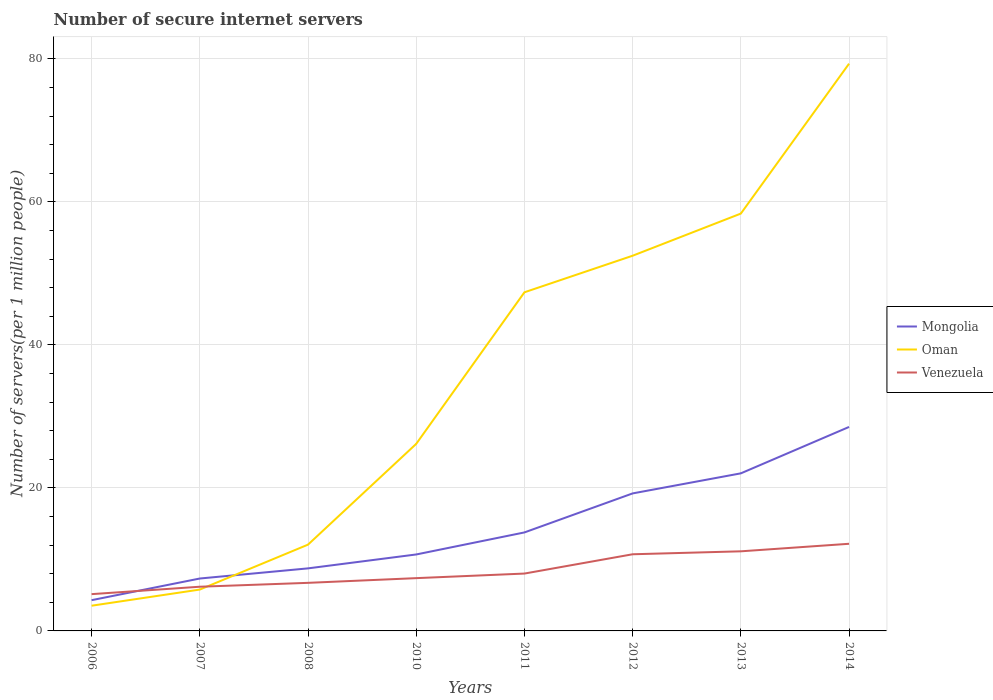Across all years, what is the maximum number of secure internet servers in Mongolia?
Provide a succinct answer. 4.3. In which year was the number of secure internet servers in Mongolia maximum?
Provide a succinct answer. 2006. What is the total number of secure internet servers in Mongolia in the graph?
Keep it short and to the point. -3.03. What is the difference between the highest and the second highest number of secure internet servers in Mongolia?
Your answer should be compact. 24.22. How many lines are there?
Make the answer very short. 3. How many years are there in the graph?
Keep it short and to the point. 8. Does the graph contain grids?
Ensure brevity in your answer.  Yes. Where does the legend appear in the graph?
Ensure brevity in your answer.  Center right. How many legend labels are there?
Provide a short and direct response. 3. How are the legend labels stacked?
Offer a terse response. Vertical. What is the title of the graph?
Your response must be concise. Number of secure internet servers. Does "Macao" appear as one of the legend labels in the graph?
Ensure brevity in your answer.  No. What is the label or title of the X-axis?
Your response must be concise. Years. What is the label or title of the Y-axis?
Ensure brevity in your answer.  Number of servers(per 1 million people). What is the Number of servers(per 1 million people) of Mongolia in 2006?
Provide a succinct answer. 4.3. What is the Number of servers(per 1 million people) of Oman in 2006?
Keep it short and to the point. 3.52. What is the Number of servers(per 1 million people) in Venezuela in 2006?
Keep it short and to the point. 5.14. What is the Number of servers(per 1 million people) in Mongolia in 2007?
Your response must be concise. 7.33. What is the Number of servers(per 1 million people) of Oman in 2007?
Offer a very short reply. 5.78. What is the Number of servers(per 1 million people) in Venezuela in 2007?
Your response must be concise. 6.18. What is the Number of servers(per 1 million people) in Mongolia in 2008?
Ensure brevity in your answer.  8.75. What is the Number of servers(per 1 million people) in Oman in 2008?
Offer a terse response. 12.07. What is the Number of servers(per 1 million people) in Venezuela in 2008?
Provide a short and direct response. 6.72. What is the Number of servers(per 1 million people) in Mongolia in 2010?
Provide a succinct answer. 10.69. What is the Number of servers(per 1 million people) of Oman in 2010?
Your answer should be very brief. 26.16. What is the Number of servers(per 1 million people) of Venezuela in 2010?
Make the answer very short. 7.38. What is the Number of servers(per 1 million people) of Mongolia in 2011?
Offer a very short reply. 13.77. What is the Number of servers(per 1 million people) in Oman in 2011?
Your answer should be very brief. 47.35. What is the Number of servers(per 1 million people) in Venezuela in 2011?
Offer a very short reply. 8.02. What is the Number of servers(per 1 million people) in Mongolia in 2012?
Your answer should be very brief. 19.23. What is the Number of servers(per 1 million people) in Oman in 2012?
Your answer should be very brief. 52.47. What is the Number of servers(per 1 million people) of Venezuela in 2012?
Give a very brief answer. 10.72. What is the Number of servers(per 1 million people) in Mongolia in 2013?
Offer a very short reply. 22.03. What is the Number of servers(per 1 million people) of Oman in 2013?
Your answer should be very brief. 58.36. What is the Number of servers(per 1 million people) of Venezuela in 2013?
Give a very brief answer. 11.13. What is the Number of servers(per 1 million people) in Mongolia in 2014?
Provide a short and direct response. 28.52. What is the Number of servers(per 1 million people) in Oman in 2014?
Provide a succinct answer. 79.32. What is the Number of servers(per 1 million people) of Venezuela in 2014?
Give a very brief answer. 12.18. Across all years, what is the maximum Number of servers(per 1 million people) in Mongolia?
Your response must be concise. 28.52. Across all years, what is the maximum Number of servers(per 1 million people) in Oman?
Your answer should be compact. 79.32. Across all years, what is the maximum Number of servers(per 1 million people) of Venezuela?
Keep it short and to the point. 12.18. Across all years, what is the minimum Number of servers(per 1 million people) of Mongolia?
Keep it short and to the point. 4.3. Across all years, what is the minimum Number of servers(per 1 million people) in Oman?
Your response must be concise. 3.52. Across all years, what is the minimum Number of servers(per 1 million people) of Venezuela?
Your answer should be compact. 5.14. What is the total Number of servers(per 1 million people) of Mongolia in the graph?
Your answer should be compact. 114.62. What is the total Number of servers(per 1 million people) of Oman in the graph?
Your answer should be compact. 285.02. What is the total Number of servers(per 1 million people) in Venezuela in the graph?
Give a very brief answer. 67.48. What is the difference between the Number of servers(per 1 million people) in Mongolia in 2006 and that in 2007?
Your answer should be compact. -3.03. What is the difference between the Number of servers(per 1 million people) in Oman in 2006 and that in 2007?
Your answer should be very brief. -2.26. What is the difference between the Number of servers(per 1 million people) in Venezuela in 2006 and that in 2007?
Keep it short and to the point. -1.04. What is the difference between the Number of servers(per 1 million people) of Mongolia in 2006 and that in 2008?
Make the answer very short. -4.45. What is the difference between the Number of servers(per 1 million people) in Oman in 2006 and that in 2008?
Offer a very short reply. -8.54. What is the difference between the Number of servers(per 1 million people) of Venezuela in 2006 and that in 2008?
Keep it short and to the point. -1.58. What is the difference between the Number of servers(per 1 million people) of Mongolia in 2006 and that in 2010?
Your answer should be very brief. -6.39. What is the difference between the Number of servers(per 1 million people) in Oman in 2006 and that in 2010?
Your response must be concise. -22.63. What is the difference between the Number of servers(per 1 million people) in Venezuela in 2006 and that in 2010?
Your answer should be very brief. -2.24. What is the difference between the Number of servers(per 1 million people) in Mongolia in 2006 and that in 2011?
Offer a very short reply. -9.47. What is the difference between the Number of servers(per 1 million people) in Oman in 2006 and that in 2011?
Keep it short and to the point. -43.83. What is the difference between the Number of servers(per 1 million people) of Venezuela in 2006 and that in 2011?
Offer a very short reply. -2.88. What is the difference between the Number of servers(per 1 million people) in Mongolia in 2006 and that in 2012?
Your answer should be very brief. -14.93. What is the difference between the Number of servers(per 1 million people) of Oman in 2006 and that in 2012?
Provide a succinct answer. -48.94. What is the difference between the Number of servers(per 1 million people) in Venezuela in 2006 and that in 2012?
Offer a very short reply. -5.58. What is the difference between the Number of servers(per 1 million people) in Mongolia in 2006 and that in 2013?
Keep it short and to the point. -17.73. What is the difference between the Number of servers(per 1 million people) in Oman in 2006 and that in 2013?
Your answer should be very brief. -54.83. What is the difference between the Number of servers(per 1 million people) in Venezuela in 2006 and that in 2013?
Offer a terse response. -5.99. What is the difference between the Number of servers(per 1 million people) of Mongolia in 2006 and that in 2014?
Offer a very short reply. -24.22. What is the difference between the Number of servers(per 1 million people) in Oman in 2006 and that in 2014?
Your response must be concise. -75.79. What is the difference between the Number of servers(per 1 million people) in Venezuela in 2006 and that in 2014?
Offer a terse response. -7.04. What is the difference between the Number of servers(per 1 million people) in Mongolia in 2007 and that in 2008?
Provide a short and direct response. -1.42. What is the difference between the Number of servers(per 1 million people) of Oman in 2007 and that in 2008?
Give a very brief answer. -6.28. What is the difference between the Number of servers(per 1 million people) in Venezuela in 2007 and that in 2008?
Provide a succinct answer. -0.54. What is the difference between the Number of servers(per 1 million people) in Mongolia in 2007 and that in 2010?
Make the answer very short. -3.36. What is the difference between the Number of servers(per 1 million people) in Oman in 2007 and that in 2010?
Make the answer very short. -20.37. What is the difference between the Number of servers(per 1 million people) in Venezuela in 2007 and that in 2010?
Your answer should be compact. -1.2. What is the difference between the Number of servers(per 1 million people) of Mongolia in 2007 and that in 2011?
Give a very brief answer. -6.44. What is the difference between the Number of servers(per 1 million people) of Oman in 2007 and that in 2011?
Give a very brief answer. -41.57. What is the difference between the Number of servers(per 1 million people) in Venezuela in 2007 and that in 2011?
Give a very brief answer. -1.84. What is the difference between the Number of servers(per 1 million people) of Mongolia in 2007 and that in 2012?
Offer a very short reply. -11.9. What is the difference between the Number of servers(per 1 million people) in Oman in 2007 and that in 2012?
Your answer should be very brief. -46.68. What is the difference between the Number of servers(per 1 million people) in Venezuela in 2007 and that in 2012?
Make the answer very short. -4.54. What is the difference between the Number of servers(per 1 million people) in Mongolia in 2007 and that in 2013?
Offer a very short reply. -14.71. What is the difference between the Number of servers(per 1 million people) of Oman in 2007 and that in 2013?
Keep it short and to the point. -52.58. What is the difference between the Number of servers(per 1 million people) in Venezuela in 2007 and that in 2013?
Give a very brief answer. -4.95. What is the difference between the Number of servers(per 1 million people) of Mongolia in 2007 and that in 2014?
Give a very brief answer. -21.2. What is the difference between the Number of servers(per 1 million people) of Oman in 2007 and that in 2014?
Offer a very short reply. -73.54. What is the difference between the Number of servers(per 1 million people) of Venezuela in 2007 and that in 2014?
Offer a terse response. -6. What is the difference between the Number of servers(per 1 million people) of Mongolia in 2008 and that in 2010?
Your answer should be very brief. -1.94. What is the difference between the Number of servers(per 1 million people) in Oman in 2008 and that in 2010?
Ensure brevity in your answer.  -14.09. What is the difference between the Number of servers(per 1 million people) in Venezuela in 2008 and that in 2010?
Provide a succinct answer. -0.66. What is the difference between the Number of servers(per 1 million people) in Mongolia in 2008 and that in 2011?
Your answer should be very brief. -5.03. What is the difference between the Number of servers(per 1 million people) in Oman in 2008 and that in 2011?
Give a very brief answer. -35.29. What is the difference between the Number of servers(per 1 million people) of Venezuela in 2008 and that in 2011?
Keep it short and to the point. -1.3. What is the difference between the Number of servers(per 1 million people) in Mongolia in 2008 and that in 2012?
Your answer should be compact. -10.48. What is the difference between the Number of servers(per 1 million people) of Oman in 2008 and that in 2012?
Provide a short and direct response. -40.4. What is the difference between the Number of servers(per 1 million people) in Venezuela in 2008 and that in 2012?
Provide a short and direct response. -4. What is the difference between the Number of servers(per 1 million people) in Mongolia in 2008 and that in 2013?
Your response must be concise. -13.29. What is the difference between the Number of servers(per 1 million people) in Oman in 2008 and that in 2013?
Keep it short and to the point. -46.29. What is the difference between the Number of servers(per 1 million people) in Venezuela in 2008 and that in 2013?
Your answer should be very brief. -4.41. What is the difference between the Number of servers(per 1 million people) of Mongolia in 2008 and that in 2014?
Your response must be concise. -19.78. What is the difference between the Number of servers(per 1 million people) of Oman in 2008 and that in 2014?
Provide a short and direct response. -67.25. What is the difference between the Number of servers(per 1 million people) of Venezuela in 2008 and that in 2014?
Ensure brevity in your answer.  -5.46. What is the difference between the Number of servers(per 1 million people) of Mongolia in 2010 and that in 2011?
Ensure brevity in your answer.  -3.08. What is the difference between the Number of servers(per 1 million people) in Oman in 2010 and that in 2011?
Offer a very short reply. -21.19. What is the difference between the Number of servers(per 1 million people) in Venezuela in 2010 and that in 2011?
Give a very brief answer. -0.64. What is the difference between the Number of servers(per 1 million people) of Mongolia in 2010 and that in 2012?
Keep it short and to the point. -8.54. What is the difference between the Number of servers(per 1 million people) in Oman in 2010 and that in 2012?
Your answer should be very brief. -26.31. What is the difference between the Number of servers(per 1 million people) in Venezuela in 2010 and that in 2012?
Offer a very short reply. -3.34. What is the difference between the Number of servers(per 1 million people) in Mongolia in 2010 and that in 2013?
Provide a succinct answer. -11.34. What is the difference between the Number of servers(per 1 million people) of Oman in 2010 and that in 2013?
Provide a succinct answer. -32.2. What is the difference between the Number of servers(per 1 million people) of Venezuela in 2010 and that in 2013?
Ensure brevity in your answer.  -3.75. What is the difference between the Number of servers(per 1 million people) in Mongolia in 2010 and that in 2014?
Ensure brevity in your answer.  -17.83. What is the difference between the Number of servers(per 1 million people) of Oman in 2010 and that in 2014?
Offer a terse response. -53.16. What is the difference between the Number of servers(per 1 million people) of Venezuela in 2010 and that in 2014?
Your response must be concise. -4.8. What is the difference between the Number of servers(per 1 million people) in Mongolia in 2011 and that in 2012?
Provide a short and direct response. -5.46. What is the difference between the Number of servers(per 1 million people) in Oman in 2011 and that in 2012?
Make the answer very short. -5.11. What is the difference between the Number of servers(per 1 million people) of Venezuela in 2011 and that in 2012?
Offer a very short reply. -2.7. What is the difference between the Number of servers(per 1 million people) in Mongolia in 2011 and that in 2013?
Provide a short and direct response. -8.26. What is the difference between the Number of servers(per 1 million people) of Oman in 2011 and that in 2013?
Keep it short and to the point. -11.01. What is the difference between the Number of servers(per 1 million people) of Venezuela in 2011 and that in 2013?
Keep it short and to the point. -3.11. What is the difference between the Number of servers(per 1 million people) of Mongolia in 2011 and that in 2014?
Provide a short and direct response. -14.75. What is the difference between the Number of servers(per 1 million people) in Oman in 2011 and that in 2014?
Provide a succinct answer. -31.97. What is the difference between the Number of servers(per 1 million people) in Venezuela in 2011 and that in 2014?
Give a very brief answer. -4.17. What is the difference between the Number of servers(per 1 million people) in Mongolia in 2012 and that in 2013?
Keep it short and to the point. -2.81. What is the difference between the Number of servers(per 1 million people) of Oman in 2012 and that in 2013?
Ensure brevity in your answer.  -5.89. What is the difference between the Number of servers(per 1 million people) of Venezuela in 2012 and that in 2013?
Make the answer very short. -0.41. What is the difference between the Number of servers(per 1 million people) of Mongolia in 2012 and that in 2014?
Ensure brevity in your answer.  -9.3. What is the difference between the Number of servers(per 1 million people) of Oman in 2012 and that in 2014?
Offer a terse response. -26.85. What is the difference between the Number of servers(per 1 million people) of Venezuela in 2012 and that in 2014?
Provide a short and direct response. -1.47. What is the difference between the Number of servers(per 1 million people) in Mongolia in 2013 and that in 2014?
Make the answer very short. -6.49. What is the difference between the Number of servers(per 1 million people) of Oman in 2013 and that in 2014?
Keep it short and to the point. -20.96. What is the difference between the Number of servers(per 1 million people) of Venezuela in 2013 and that in 2014?
Offer a very short reply. -1.05. What is the difference between the Number of servers(per 1 million people) in Mongolia in 2006 and the Number of servers(per 1 million people) in Oman in 2007?
Offer a very short reply. -1.48. What is the difference between the Number of servers(per 1 million people) in Mongolia in 2006 and the Number of servers(per 1 million people) in Venezuela in 2007?
Your response must be concise. -1.88. What is the difference between the Number of servers(per 1 million people) in Oman in 2006 and the Number of servers(per 1 million people) in Venezuela in 2007?
Keep it short and to the point. -2.66. What is the difference between the Number of servers(per 1 million people) of Mongolia in 2006 and the Number of servers(per 1 million people) of Oman in 2008?
Provide a short and direct response. -7.77. What is the difference between the Number of servers(per 1 million people) of Mongolia in 2006 and the Number of servers(per 1 million people) of Venezuela in 2008?
Your answer should be compact. -2.42. What is the difference between the Number of servers(per 1 million people) of Oman in 2006 and the Number of servers(per 1 million people) of Venezuela in 2008?
Make the answer very short. -3.2. What is the difference between the Number of servers(per 1 million people) of Mongolia in 2006 and the Number of servers(per 1 million people) of Oman in 2010?
Offer a very short reply. -21.86. What is the difference between the Number of servers(per 1 million people) in Mongolia in 2006 and the Number of servers(per 1 million people) in Venezuela in 2010?
Your answer should be very brief. -3.08. What is the difference between the Number of servers(per 1 million people) in Oman in 2006 and the Number of servers(per 1 million people) in Venezuela in 2010?
Provide a short and direct response. -3.86. What is the difference between the Number of servers(per 1 million people) of Mongolia in 2006 and the Number of servers(per 1 million people) of Oman in 2011?
Offer a very short reply. -43.05. What is the difference between the Number of servers(per 1 million people) of Mongolia in 2006 and the Number of servers(per 1 million people) of Venezuela in 2011?
Keep it short and to the point. -3.72. What is the difference between the Number of servers(per 1 million people) of Oman in 2006 and the Number of servers(per 1 million people) of Venezuela in 2011?
Provide a succinct answer. -4.49. What is the difference between the Number of servers(per 1 million people) of Mongolia in 2006 and the Number of servers(per 1 million people) of Oman in 2012?
Offer a terse response. -48.17. What is the difference between the Number of servers(per 1 million people) of Mongolia in 2006 and the Number of servers(per 1 million people) of Venezuela in 2012?
Give a very brief answer. -6.42. What is the difference between the Number of servers(per 1 million people) in Oman in 2006 and the Number of servers(per 1 million people) in Venezuela in 2012?
Give a very brief answer. -7.19. What is the difference between the Number of servers(per 1 million people) in Mongolia in 2006 and the Number of servers(per 1 million people) in Oman in 2013?
Give a very brief answer. -54.06. What is the difference between the Number of servers(per 1 million people) in Mongolia in 2006 and the Number of servers(per 1 million people) in Venezuela in 2013?
Keep it short and to the point. -6.83. What is the difference between the Number of servers(per 1 million people) in Oman in 2006 and the Number of servers(per 1 million people) in Venezuela in 2013?
Give a very brief answer. -7.61. What is the difference between the Number of servers(per 1 million people) in Mongolia in 2006 and the Number of servers(per 1 million people) in Oman in 2014?
Offer a terse response. -75.02. What is the difference between the Number of servers(per 1 million people) in Mongolia in 2006 and the Number of servers(per 1 million people) in Venezuela in 2014?
Your answer should be very brief. -7.89. What is the difference between the Number of servers(per 1 million people) of Oman in 2006 and the Number of servers(per 1 million people) of Venezuela in 2014?
Make the answer very short. -8.66. What is the difference between the Number of servers(per 1 million people) of Mongolia in 2007 and the Number of servers(per 1 million people) of Oman in 2008?
Give a very brief answer. -4.74. What is the difference between the Number of servers(per 1 million people) in Mongolia in 2007 and the Number of servers(per 1 million people) in Venezuela in 2008?
Your response must be concise. 0.61. What is the difference between the Number of servers(per 1 million people) of Oman in 2007 and the Number of servers(per 1 million people) of Venezuela in 2008?
Ensure brevity in your answer.  -0.94. What is the difference between the Number of servers(per 1 million people) of Mongolia in 2007 and the Number of servers(per 1 million people) of Oman in 2010?
Give a very brief answer. -18.83. What is the difference between the Number of servers(per 1 million people) in Mongolia in 2007 and the Number of servers(per 1 million people) in Venezuela in 2010?
Your response must be concise. -0.05. What is the difference between the Number of servers(per 1 million people) in Oman in 2007 and the Number of servers(per 1 million people) in Venezuela in 2010?
Offer a terse response. -1.6. What is the difference between the Number of servers(per 1 million people) in Mongolia in 2007 and the Number of servers(per 1 million people) in Oman in 2011?
Provide a succinct answer. -40.02. What is the difference between the Number of servers(per 1 million people) in Mongolia in 2007 and the Number of servers(per 1 million people) in Venezuela in 2011?
Your answer should be compact. -0.69. What is the difference between the Number of servers(per 1 million people) of Oman in 2007 and the Number of servers(per 1 million people) of Venezuela in 2011?
Your answer should be compact. -2.24. What is the difference between the Number of servers(per 1 million people) of Mongolia in 2007 and the Number of servers(per 1 million people) of Oman in 2012?
Provide a short and direct response. -45.14. What is the difference between the Number of servers(per 1 million people) in Mongolia in 2007 and the Number of servers(per 1 million people) in Venezuela in 2012?
Your response must be concise. -3.39. What is the difference between the Number of servers(per 1 million people) in Oman in 2007 and the Number of servers(per 1 million people) in Venezuela in 2012?
Provide a succinct answer. -4.94. What is the difference between the Number of servers(per 1 million people) in Mongolia in 2007 and the Number of servers(per 1 million people) in Oman in 2013?
Your response must be concise. -51.03. What is the difference between the Number of servers(per 1 million people) in Mongolia in 2007 and the Number of servers(per 1 million people) in Venezuela in 2013?
Your response must be concise. -3.8. What is the difference between the Number of servers(per 1 million people) in Oman in 2007 and the Number of servers(per 1 million people) in Venezuela in 2013?
Keep it short and to the point. -5.35. What is the difference between the Number of servers(per 1 million people) of Mongolia in 2007 and the Number of servers(per 1 million people) of Oman in 2014?
Your answer should be very brief. -71.99. What is the difference between the Number of servers(per 1 million people) of Mongolia in 2007 and the Number of servers(per 1 million people) of Venezuela in 2014?
Make the answer very short. -4.86. What is the difference between the Number of servers(per 1 million people) of Oman in 2007 and the Number of servers(per 1 million people) of Venezuela in 2014?
Your answer should be compact. -6.4. What is the difference between the Number of servers(per 1 million people) in Mongolia in 2008 and the Number of servers(per 1 million people) in Oman in 2010?
Your answer should be very brief. -17.41. What is the difference between the Number of servers(per 1 million people) in Mongolia in 2008 and the Number of servers(per 1 million people) in Venezuela in 2010?
Provide a short and direct response. 1.37. What is the difference between the Number of servers(per 1 million people) in Oman in 2008 and the Number of servers(per 1 million people) in Venezuela in 2010?
Offer a terse response. 4.68. What is the difference between the Number of servers(per 1 million people) in Mongolia in 2008 and the Number of servers(per 1 million people) in Oman in 2011?
Make the answer very short. -38.61. What is the difference between the Number of servers(per 1 million people) in Mongolia in 2008 and the Number of servers(per 1 million people) in Venezuela in 2011?
Provide a succinct answer. 0.73. What is the difference between the Number of servers(per 1 million people) in Oman in 2008 and the Number of servers(per 1 million people) in Venezuela in 2011?
Give a very brief answer. 4.05. What is the difference between the Number of servers(per 1 million people) of Mongolia in 2008 and the Number of servers(per 1 million people) of Oman in 2012?
Your answer should be compact. -43.72. What is the difference between the Number of servers(per 1 million people) in Mongolia in 2008 and the Number of servers(per 1 million people) in Venezuela in 2012?
Make the answer very short. -1.97. What is the difference between the Number of servers(per 1 million people) of Oman in 2008 and the Number of servers(per 1 million people) of Venezuela in 2012?
Provide a succinct answer. 1.35. What is the difference between the Number of servers(per 1 million people) of Mongolia in 2008 and the Number of servers(per 1 million people) of Oman in 2013?
Your answer should be compact. -49.61. What is the difference between the Number of servers(per 1 million people) in Mongolia in 2008 and the Number of servers(per 1 million people) in Venezuela in 2013?
Provide a succinct answer. -2.38. What is the difference between the Number of servers(per 1 million people) of Oman in 2008 and the Number of servers(per 1 million people) of Venezuela in 2013?
Provide a succinct answer. 0.93. What is the difference between the Number of servers(per 1 million people) of Mongolia in 2008 and the Number of servers(per 1 million people) of Oman in 2014?
Give a very brief answer. -70.57. What is the difference between the Number of servers(per 1 million people) in Mongolia in 2008 and the Number of servers(per 1 million people) in Venezuela in 2014?
Offer a terse response. -3.44. What is the difference between the Number of servers(per 1 million people) of Oman in 2008 and the Number of servers(per 1 million people) of Venezuela in 2014?
Offer a terse response. -0.12. What is the difference between the Number of servers(per 1 million people) of Mongolia in 2010 and the Number of servers(per 1 million people) of Oman in 2011?
Offer a very short reply. -36.66. What is the difference between the Number of servers(per 1 million people) in Mongolia in 2010 and the Number of servers(per 1 million people) in Venezuela in 2011?
Keep it short and to the point. 2.67. What is the difference between the Number of servers(per 1 million people) of Oman in 2010 and the Number of servers(per 1 million people) of Venezuela in 2011?
Provide a short and direct response. 18.14. What is the difference between the Number of servers(per 1 million people) of Mongolia in 2010 and the Number of servers(per 1 million people) of Oman in 2012?
Ensure brevity in your answer.  -41.77. What is the difference between the Number of servers(per 1 million people) in Mongolia in 2010 and the Number of servers(per 1 million people) in Venezuela in 2012?
Provide a short and direct response. -0.03. What is the difference between the Number of servers(per 1 million people) in Oman in 2010 and the Number of servers(per 1 million people) in Venezuela in 2012?
Your response must be concise. 15.44. What is the difference between the Number of servers(per 1 million people) of Mongolia in 2010 and the Number of servers(per 1 million people) of Oman in 2013?
Ensure brevity in your answer.  -47.67. What is the difference between the Number of servers(per 1 million people) in Mongolia in 2010 and the Number of servers(per 1 million people) in Venezuela in 2013?
Provide a short and direct response. -0.44. What is the difference between the Number of servers(per 1 million people) of Oman in 2010 and the Number of servers(per 1 million people) of Venezuela in 2013?
Offer a very short reply. 15.03. What is the difference between the Number of servers(per 1 million people) of Mongolia in 2010 and the Number of servers(per 1 million people) of Oman in 2014?
Offer a very short reply. -68.63. What is the difference between the Number of servers(per 1 million people) of Mongolia in 2010 and the Number of servers(per 1 million people) of Venezuela in 2014?
Offer a terse response. -1.49. What is the difference between the Number of servers(per 1 million people) of Oman in 2010 and the Number of servers(per 1 million people) of Venezuela in 2014?
Provide a short and direct response. 13.97. What is the difference between the Number of servers(per 1 million people) in Mongolia in 2011 and the Number of servers(per 1 million people) in Oman in 2012?
Provide a succinct answer. -38.69. What is the difference between the Number of servers(per 1 million people) of Mongolia in 2011 and the Number of servers(per 1 million people) of Venezuela in 2012?
Your answer should be compact. 3.05. What is the difference between the Number of servers(per 1 million people) in Oman in 2011 and the Number of servers(per 1 million people) in Venezuela in 2012?
Ensure brevity in your answer.  36.63. What is the difference between the Number of servers(per 1 million people) in Mongolia in 2011 and the Number of servers(per 1 million people) in Oman in 2013?
Give a very brief answer. -44.59. What is the difference between the Number of servers(per 1 million people) in Mongolia in 2011 and the Number of servers(per 1 million people) in Venezuela in 2013?
Keep it short and to the point. 2.64. What is the difference between the Number of servers(per 1 million people) of Oman in 2011 and the Number of servers(per 1 million people) of Venezuela in 2013?
Ensure brevity in your answer.  36.22. What is the difference between the Number of servers(per 1 million people) in Mongolia in 2011 and the Number of servers(per 1 million people) in Oman in 2014?
Provide a short and direct response. -65.55. What is the difference between the Number of servers(per 1 million people) in Mongolia in 2011 and the Number of servers(per 1 million people) in Venezuela in 2014?
Offer a very short reply. 1.59. What is the difference between the Number of servers(per 1 million people) of Oman in 2011 and the Number of servers(per 1 million people) of Venezuela in 2014?
Give a very brief answer. 35.17. What is the difference between the Number of servers(per 1 million people) in Mongolia in 2012 and the Number of servers(per 1 million people) in Oman in 2013?
Keep it short and to the point. -39.13. What is the difference between the Number of servers(per 1 million people) of Mongolia in 2012 and the Number of servers(per 1 million people) of Venezuela in 2013?
Ensure brevity in your answer.  8.1. What is the difference between the Number of servers(per 1 million people) of Oman in 2012 and the Number of servers(per 1 million people) of Venezuela in 2013?
Your answer should be very brief. 41.33. What is the difference between the Number of servers(per 1 million people) in Mongolia in 2012 and the Number of servers(per 1 million people) in Oman in 2014?
Provide a succinct answer. -60.09. What is the difference between the Number of servers(per 1 million people) of Mongolia in 2012 and the Number of servers(per 1 million people) of Venezuela in 2014?
Provide a short and direct response. 7.04. What is the difference between the Number of servers(per 1 million people) of Oman in 2012 and the Number of servers(per 1 million people) of Venezuela in 2014?
Your response must be concise. 40.28. What is the difference between the Number of servers(per 1 million people) of Mongolia in 2013 and the Number of servers(per 1 million people) of Oman in 2014?
Ensure brevity in your answer.  -57.28. What is the difference between the Number of servers(per 1 million people) of Mongolia in 2013 and the Number of servers(per 1 million people) of Venezuela in 2014?
Keep it short and to the point. 9.85. What is the difference between the Number of servers(per 1 million people) in Oman in 2013 and the Number of servers(per 1 million people) in Venezuela in 2014?
Your response must be concise. 46.17. What is the average Number of servers(per 1 million people) of Mongolia per year?
Keep it short and to the point. 14.33. What is the average Number of servers(per 1 million people) in Oman per year?
Offer a terse response. 35.63. What is the average Number of servers(per 1 million people) in Venezuela per year?
Your response must be concise. 8.43. In the year 2006, what is the difference between the Number of servers(per 1 million people) of Mongolia and Number of servers(per 1 million people) of Oman?
Give a very brief answer. 0.77. In the year 2006, what is the difference between the Number of servers(per 1 million people) of Mongolia and Number of servers(per 1 million people) of Venezuela?
Provide a succinct answer. -0.84. In the year 2006, what is the difference between the Number of servers(per 1 million people) in Oman and Number of servers(per 1 million people) in Venezuela?
Your answer should be compact. -1.62. In the year 2007, what is the difference between the Number of servers(per 1 million people) in Mongolia and Number of servers(per 1 million people) in Oman?
Your response must be concise. 1.54. In the year 2007, what is the difference between the Number of servers(per 1 million people) of Mongolia and Number of servers(per 1 million people) of Venezuela?
Your response must be concise. 1.15. In the year 2007, what is the difference between the Number of servers(per 1 million people) of Oman and Number of servers(per 1 million people) of Venezuela?
Keep it short and to the point. -0.4. In the year 2008, what is the difference between the Number of servers(per 1 million people) in Mongolia and Number of servers(per 1 million people) in Oman?
Provide a short and direct response. -3.32. In the year 2008, what is the difference between the Number of servers(per 1 million people) in Mongolia and Number of servers(per 1 million people) in Venezuela?
Your answer should be compact. 2.02. In the year 2008, what is the difference between the Number of servers(per 1 million people) of Oman and Number of servers(per 1 million people) of Venezuela?
Make the answer very short. 5.34. In the year 2010, what is the difference between the Number of servers(per 1 million people) in Mongolia and Number of servers(per 1 million people) in Oman?
Make the answer very short. -15.47. In the year 2010, what is the difference between the Number of servers(per 1 million people) in Mongolia and Number of servers(per 1 million people) in Venezuela?
Give a very brief answer. 3.31. In the year 2010, what is the difference between the Number of servers(per 1 million people) in Oman and Number of servers(per 1 million people) in Venezuela?
Provide a short and direct response. 18.78. In the year 2011, what is the difference between the Number of servers(per 1 million people) in Mongolia and Number of servers(per 1 million people) in Oman?
Your answer should be very brief. -33.58. In the year 2011, what is the difference between the Number of servers(per 1 million people) in Mongolia and Number of servers(per 1 million people) in Venezuela?
Offer a terse response. 5.75. In the year 2011, what is the difference between the Number of servers(per 1 million people) in Oman and Number of servers(per 1 million people) in Venezuela?
Your answer should be compact. 39.33. In the year 2012, what is the difference between the Number of servers(per 1 million people) of Mongolia and Number of servers(per 1 million people) of Oman?
Offer a very short reply. -33.24. In the year 2012, what is the difference between the Number of servers(per 1 million people) of Mongolia and Number of servers(per 1 million people) of Venezuela?
Your response must be concise. 8.51. In the year 2012, what is the difference between the Number of servers(per 1 million people) in Oman and Number of servers(per 1 million people) in Venezuela?
Offer a terse response. 41.75. In the year 2013, what is the difference between the Number of servers(per 1 million people) of Mongolia and Number of servers(per 1 million people) of Oman?
Keep it short and to the point. -36.32. In the year 2013, what is the difference between the Number of servers(per 1 million people) of Mongolia and Number of servers(per 1 million people) of Venezuela?
Keep it short and to the point. 10.9. In the year 2013, what is the difference between the Number of servers(per 1 million people) in Oman and Number of servers(per 1 million people) in Venezuela?
Offer a very short reply. 47.23. In the year 2014, what is the difference between the Number of servers(per 1 million people) in Mongolia and Number of servers(per 1 million people) in Oman?
Your answer should be compact. -50.8. In the year 2014, what is the difference between the Number of servers(per 1 million people) of Mongolia and Number of servers(per 1 million people) of Venezuela?
Give a very brief answer. 16.34. In the year 2014, what is the difference between the Number of servers(per 1 million people) in Oman and Number of servers(per 1 million people) in Venezuela?
Offer a terse response. 67.13. What is the ratio of the Number of servers(per 1 million people) in Mongolia in 2006 to that in 2007?
Provide a succinct answer. 0.59. What is the ratio of the Number of servers(per 1 million people) in Oman in 2006 to that in 2007?
Offer a terse response. 0.61. What is the ratio of the Number of servers(per 1 million people) in Venezuela in 2006 to that in 2007?
Offer a very short reply. 0.83. What is the ratio of the Number of servers(per 1 million people) in Mongolia in 2006 to that in 2008?
Provide a succinct answer. 0.49. What is the ratio of the Number of servers(per 1 million people) of Oman in 2006 to that in 2008?
Provide a succinct answer. 0.29. What is the ratio of the Number of servers(per 1 million people) in Venezuela in 2006 to that in 2008?
Provide a short and direct response. 0.77. What is the ratio of the Number of servers(per 1 million people) of Mongolia in 2006 to that in 2010?
Give a very brief answer. 0.4. What is the ratio of the Number of servers(per 1 million people) in Oman in 2006 to that in 2010?
Your response must be concise. 0.13. What is the ratio of the Number of servers(per 1 million people) of Venezuela in 2006 to that in 2010?
Offer a terse response. 0.7. What is the ratio of the Number of servers(per 1 million people) of Mongolia in 2006 to that in 2011?
Offer a very short reply. 0.31. What is the ratio of the Number of servers(per 1 million people) in Oman in 2006 to that in 2011?
Keep it short and to the point. 0.07. What is the ratio of the Number of servers(per 1 million people) in Venezuela in 2006 to that in 2011?
Provide a succinct answer. 0.64. What is the ratio of the Number of servers(per 1 million people) in Mongolia in 2006 to that in 2012?
Your response must be concise. 0.22. What is the ratio of the Number of servers(per 1 million people) of Oman in 2006 to that in 2012?
Provide a succinct answer. 0.07. What is the ratio of the Number of servers(per 1 million people) in Venezuela in 2006 to that in 2012?
Give a very brief answer. 0.48. What is the ratio of the Number of servers(per 1 million people) of Mongolia in 2006 to that in 2013?
Offer a terse response. 0.2. What is the ratio of the Number of servers(per 1 million people) in Oman in 2006 to that in 2013?
Your response must be concise. 0.06. What is the ratio of the Number of servers(per 1 million people) in Venezuela in 2006 to that in 2013?
Make the answer very short. 0.46. What is the ratio of the Number of servers(per 1 million people) of Mongolia in 2006 to that in 2014?
Your answer should be compact. 0.15. What is the ratio of the Number of servers(per 1 million people) of Oman in 2006 to that in 2014?
Provide a succinct answer. 0.04. What is the ratio of the Number of servers(per 1 million people) of Venezuela in 2006 to that in 2014?
Give a very brief answer. 0.42. What is the ratio of the Number of servers(per 1 million people) in Mongolia in 2007 to that in 2008?
Give a very brief answer. 0.84. What is the ratio of the Number of servers(per 1 million people) in Oman in 2007 to that in 2008?
Offer a terse response. 0.48. What is the ratio of the Number of servers(per 1 million people) in Venezuela in 2007 to that in 2008?
Ensure brevity in your answer.  0.92. What is the ratio of the Number of servers(per 1 million people) in Mongolia in 2007 to that in 2010?
Give a very brief answer. 0.69. What is the ratio of the Number of servers(per 1 million people) of Oman in 2007 to that in 2010?
Your answer should be compact. 0.22. What is the ratio of the Number of servers(per 1 million people) of Venezuela in 2007 to that in 2010?
Keep it short and to the point. 0.84. What is the ratio of the Number of servers(per 1 million people) of Mongolia in 2007 to that in 2011?
Provide a short and direct response. 0.53. What is the ratio of the Number of servers(per 1 million people) in Oman in 2007 to that in 2011?
Ensure brevity in your answer.  0.12. What is the ratio of the Number of servers(per 1 million people) in Venezuela in 2007 to that in 2011?
Your answer should be compact. 0.77. What is the ratio of the Number of servers(per 1 million people) in Mongolia in 2007 to that in 2012?
Ensure brevity in your answer.  0.38. What is the ratio of the Number of servers(per 1 million people) of Oman in 2007 to that in 2012?
Provide a succinct answer. 0.11. What is the ratio of the Number of servers(per 1 million people) of Venezuela in 2007 to that in 2012?
Your response must be concise. 0.58. What is the ratio of the Number of servers(per 1 million people) in Mongolia in 2007 to that in 2013?
Make the answer very short. 0.33. What is the ratio of the Number of servers(per 1 million people) of Oman in 2007 to that in 2013?
Keep it short and to the point. 0.1. What is the ratio of the Number of servers(per 1 million people) in Venezuela in 2007 to that in 2013?
Your response must be concise. 0.56. What is the ratio of the Number of servers(per 1 million people) in Mongolia in 2007 to that in 2014?
Offer a very short reply. 0.26. What is the ratio of the Number of servers(per 1 million people) in Oman in 2007 to that in 2014?
Offer a terse response. 0.07. What is the ratio of the Number of servers(per 1 million people) in Venezuela in 2007 to that in 2014?
Your answer should be compact. 0.51. What is the ratio of the Number of servers(per 1 million people) of Mongolia in 2008 to that in 2010?
Offer a very short reply. 0.82. What is the ratio of the Number of servers(per 1 million people) in Oman in 2008 to that in 2010?
Provide a short and direct response. 0.46. What is the ratio of the Number of servers(per 1 million people) in Venezuela in 2008 to that in 2010?
Make the answer very short. 0.91. What is the ratio of the Number of servers(per 1 million people) of Mongolia in 2008 to that in 2011?
Offer a terse response. 0.64. What is the ratio of the Number of servers(per 1 million people) in Oman in 2008 to that in 2011?
Your answer should be very brief. 0.25. What is the ratio of the Number of servers(per 1 million people) in Venezuela in 2008 to that in 2011?
Your answer should be very brief. 0.84. What is the ratio of the Number of servers(per 1 million people) in Mongolia in 2008 to that in 2012?
Keep it short and to the point. 0.45. What is the ratio of the Number of servers(per 1 million people) in Oman in 2008 to that in 2012?
Make the answer very short. 0.23. What is the ratio of the Number of servers(per 1 million people) of Venezuela in 2008 to that in 2012?
Your response must be concise. 0.63. What is the ratio of the Number of servers(per 1 million people) of Mongolia in 2008 to that in 2013?
Provide a succinct answer. 0.4. What is the ratio of the Number of servers(per 1 million people) in Oman in 2008 to that in 2013?
Provide a succinct answer. 0.21. What is the ratio of the Number of servers(per 1 million people) of Venezuela in 2008 to that in 2013?
Your answer should be compact. 0.6. What is the ratio of the Number of servers(per 1 million people) in Mongolia in 2008 to that in 2014?
Offer a terse response. 0.31. What is the ratio of the Number of servers(per 1 million people) in Oman in 2008 to that in 2014?
Your answer should be compact. 0.15. What is the ratio of the Number of servers(per 1 million people) of Venezuela in 2008 to that in 2014?
Give a very brief answer. 0.55. What is the ratio of the Number of servers(per 1 million people) in Mongolia in 2010 to that in 2011?
Make the answer very short. 0.78. What is the ratio of the Number of servers(per 1 million people) in Oman in 2010 to that in 2011?
Offer a very short reply. 0.55. What is the ratio of the Number of servers(per 1 million people) in Venezuela in 2010 to that in 2011?
Give a very brief answer. 0.92. What is the ratio of the Number of servers(per 1 million people) in Mongolia in 2010 to that in 2012?
Provide a succinct answer. 0.56. What is the ratio of the Number of servers(per 1 million people) of Oman in 2010 to that in 2012?
Provide a succinct answer. 0.5. What is the ratio of the Number of servers(per 1 million people) of Venezuela in 2010 to that in 2012?
Ensure brevity in your answer.  0.69. What is the ratio of the Number of servers(per 1 million people) of Mongolia in 2010 to that in 2013?
Offer a very short reply. 0.49. What is the ratio of the Number of servers(per 1 million people) of Oman in 2010 to that in 2013?
Provide a succinct answer. 0.45. What is the ratio of the Number of servers(per 1 million people) of Venezuela in 2010 to that in 2013?
Offer a terse response. 0.66. What is the ratio of the Number of servers(per 1 million people) of Mongolia in 2010 to that in 2014?
Your answer should be very brief. 0.37. What is the ratio of the Number of servers(per 1 million people) in Oman in 2010 to that in 2014?
Give a very brief answer. 0.33. What is the ratio of the Number of servers(per 1 million people) in Venezuela in 2010 to that in 2014?
Offer a very short reply. 0.61. What is the ratio of the Number of servers(per 1 million people) of Mongolia in 2011 to that in 2012?
Give a very brief answer. 0.72. What is the ratio of the Number of servers(per 1 million people) of Oman in 2011 to that in 2012?
Keep it short and to the point. 0.9. What is the ratio of the Number of servers(per 1 million people) in Venezuela in 2011 to that in 2012?
Ensure brevity in your answer.  0.75. What is the ratio of the Number of servers(per 1 million people) in Mongolia in 2011 to that in 2013?
Your response must be concise. 0.63. What is the ratio of the Number of servers(per 1 million people) of Oman in 2011 to that in 2013?
Your answer should be very brief. 0.81. What is the ratio of the Number of servers(per 1 million people) of Venezuela in 2011 to that in 2013?
Provide a short and direct response. 0.72. What is the ratio of the Number of servers(per 1 million people) of Mongolia in 2011 to that in 2014?
Keep it short and to the point. 0.48. What is the ratio of the Number of servers(per 1 million people) of Oman in 2011 to that in 2014?
Provide a succinct answer. 0.6. What is the ratio of the Number of servers(per 1 million people) of Venezuela in 2011 to that in 2014?
Make the answer very short. 0.66. What is the ratio of the Number of servers(per 1 million people) of Mongolia in 2012 to that in 2013?
Provide a succinct answer. 0.87. What is the ratio of the Number of servers(per 1 million people) in Oman in 2012 to that in 2013?
Give a very brief answer. 0.9. What is the ratio of the Number of servers(per 1 million people) of Venezuela in 2012 to that in 2013?
Offer a very short reply. 0.96. What is the ratio of the Number of servers(per 1 million people) in Mongolia in 2012 to that in 2014?
Provide a succinct answer. 0.67. What is the ratio of the Number of servers(per 1 million people) of Oman in 2012 to that in 2014?
Offer a terse response. 0.66. What is the ratio of the Number of servers(per 1 million people) of Venezuela in 2012 to that in 2014?
Make the answer very short. 0.88. What is the ratio of the Number of servers(per 1 million people) of Mongolia in 2013 to that in 2014?
Offer a terse response. 0.77. What is the ratio of the Number of servers(per 1 million people) of Oman in 2013 to that in 2014?
Make the answer very short. 0.74. What is the ratio of the Number of servers(per 1 million people) of Venezuela in 2013 to that in 2014?
Provide a short and direct response. 0.91. What is the difference between the highest and the second highest Number of servers(per 1 million people) of Mongolia?
Provide a succinct answer. 6.49. What is the difference between the highest and the second highest Number of servers(per 1 million people) in Oman?
Offer a terse response. 20.96. What is the difference between the highest and the second highest Number of servers(per 1 million people) in Venezuela?
Your response must be concise. 1.05. What is the difference between the highest and the lowest Number of servers(per 1 million people) in Mongolia?
Your response must be concise. 24.22. What is the difference between the highest and the lowest Number of servers(per 1 million people) of Oman?
Your response must be concise. 75.79. What is the difference between the highest and the lowest Number of servers(per 1 million people) of Venezuela?
Your answer should be compact. 7.04. 